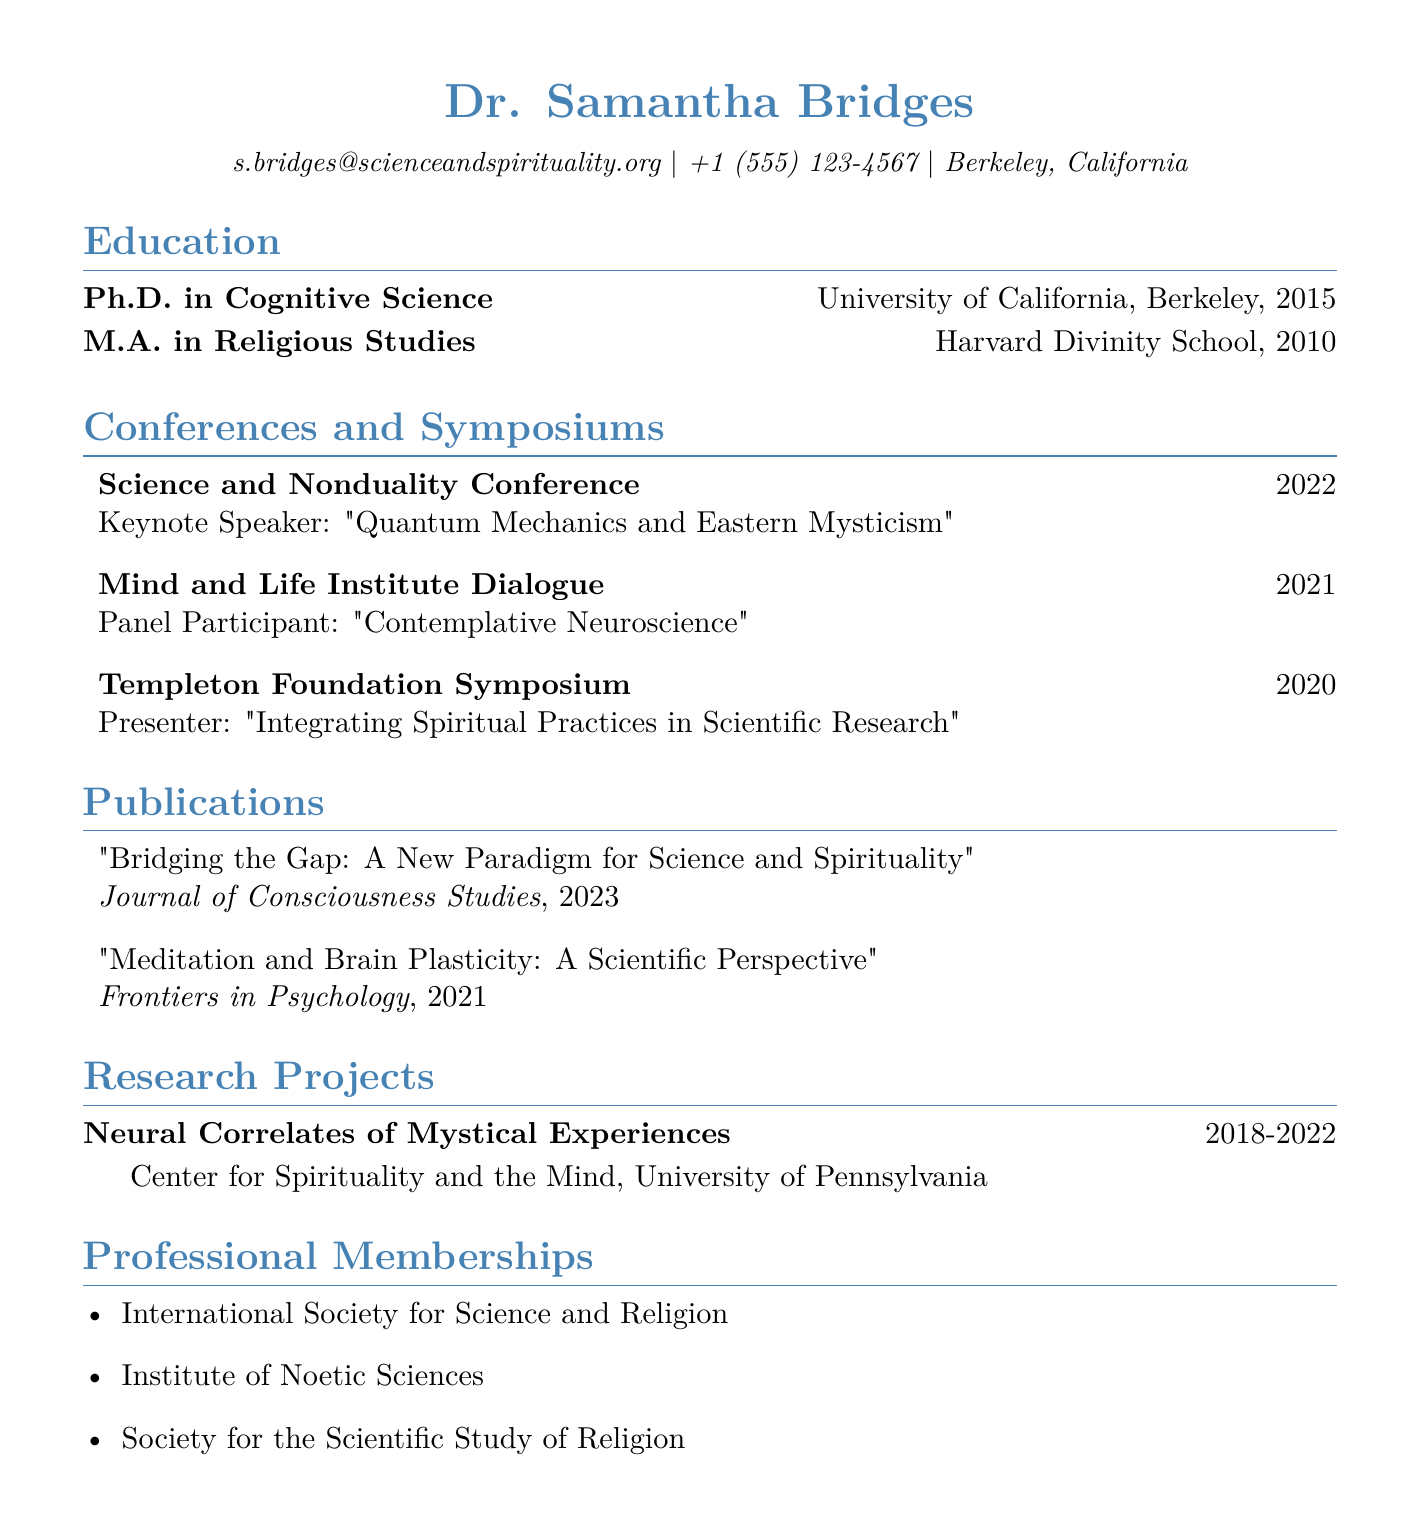What is the name of the individual in the CV? The name of the individual is provided in the personal information section of the CV.
Answer: Dr. Samantha Bridges In what year did Dr. Bridges obtain her Ph.D.? The year of obtaining the Ph.D. is listed under the education section in the CV.
Answer: 2015 What was the topic of Dr. Bridges' keynote speech at the Science and Nonduality Conference? The topic of the keynote speech is detailed in the conferences section of the CV.
Answer: Quantum Mechanics and Eastern Mysticism Where did the Mind and Life Institute Dialogue take place? The location of the Mind and Life Institute Dialogue is included in the conferences section of the CV.
Answer: Dharamsala, India How many professional memberships does Dr. Bridges have listed? The number of memberships is determined by counting the items in the professional memberships section of the CV.
Answer: 3 What is the title of the publication from 2023? The title of the most recent publication is found in the publications section of the CV.
Answer: Bridging the Gap: A New Paradigm for Science and Spirituality Which research project did Dr. Bridges work on from 2018 to 2022? The relevant research project is specified in the research projects section of the CV.
Answer: Neural Correlates of Mystical Experiences What role did Dr. Bridges play in the Templeton Foundation Symposium? The role is mentioned in the description of the Templeton Foundation Symposium in the conferences section.
Answer: Presenter Which institution did Dr. Bridges attend for her M.A. degree? The institution for her M.A. is listed in the education section of the CV.
Answer: Harvard Divinity School 